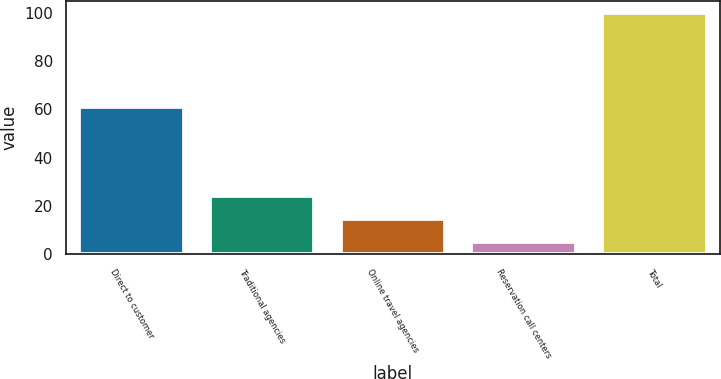Convert chart. <chart><loc_0><loc_0><loc_500><loc_500><bar_chart><fcel>Direct to customer<fcel>Traditional agencies<fcel>Online travel agencies<fcel>Reservation call centers<fcel>Total<nl><fcel>61<fcel>24<fcel>14.5<fcel>5<fcel>100<nl></chart> 